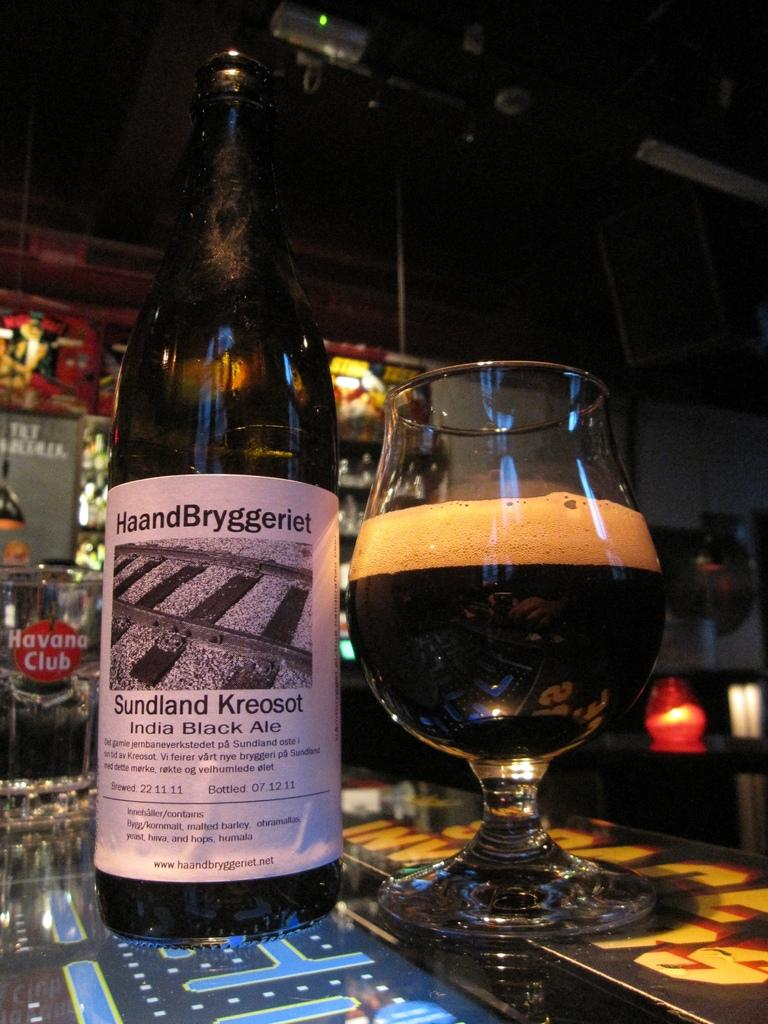What is located in the foreground of the picture? There is a bottle in the foreground of the picture. What else can be seen in the foreground of the picture? There is a glass of drink on the table in the foreground. What is visible in the background of the picture? There is a closet and a light in the background of the picture. What type of hair is visible on the bottle in the image? There is no hair visible on the bottle in the image. What kind of bait is used to attract the light in the background? There is no bait present in the image, and the light is not attracted by any bait. 